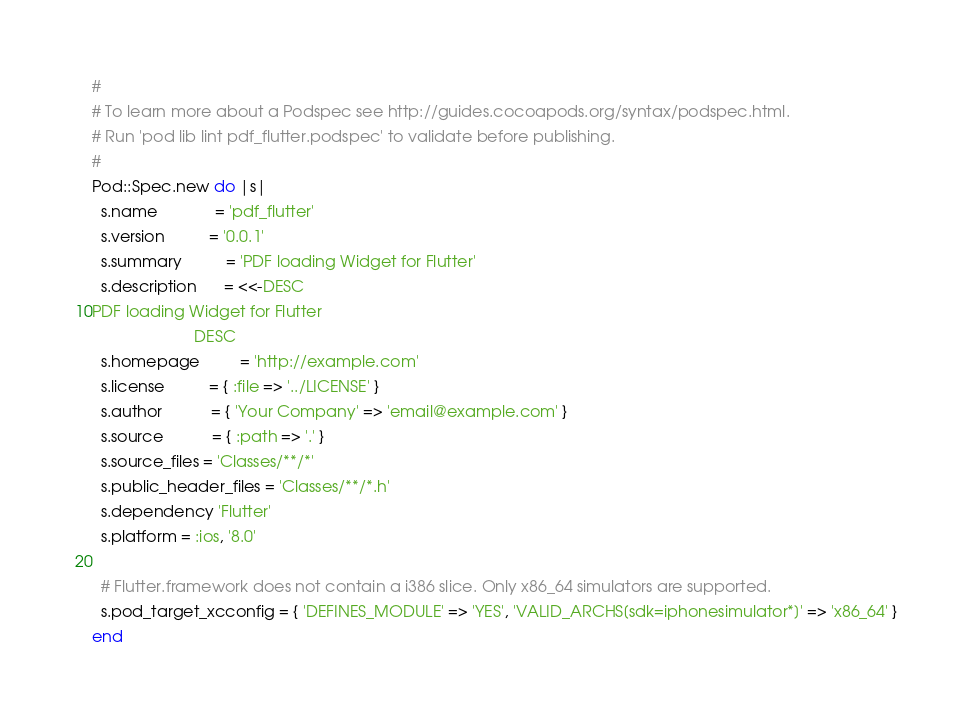<code> <loc_0><loc_0><loc_500><loc_500><_Ruby_>#
# To learn more about a Podspec see http://guides.cocoapods.org/syntax/podspec.html.
# Run 'pod lib lint pdf_flutter.podspec' to validate before publishing.
#
Pod::Spec.new do |s|
  s.name             = 'pdf_flutter'
  s.version          = '0.0.1'
  s.summary          = 'PDF loading Widget for Flutter'
  s.description      = <<-DESC
PDF loading Widget for Flutter
                       DESC
  s.homepage         = 'http://example.com'
  s.license          = { :file => '../LICENSE' }
  s.author           = { 'Your Company' => 'email@example.com' }
  s.source           = { :path => '.' }
  s.source_files = 'Classes/**/*'
  s.public_header_files = 'Classes/**/*.h'
  s.dependency 'Flutter'
  s.platform = :ios, '8.0'

  # Flutter.framework does not contain a i386 slice. Only x86_64 simulators are supported.
  s.pod_target_xcconfig = { 'DEFINES_MODULE' => 'YES', 'VALID_ARCHS[sdk=iphonesimulator*]' => 'x86_64' }
end
</code> 